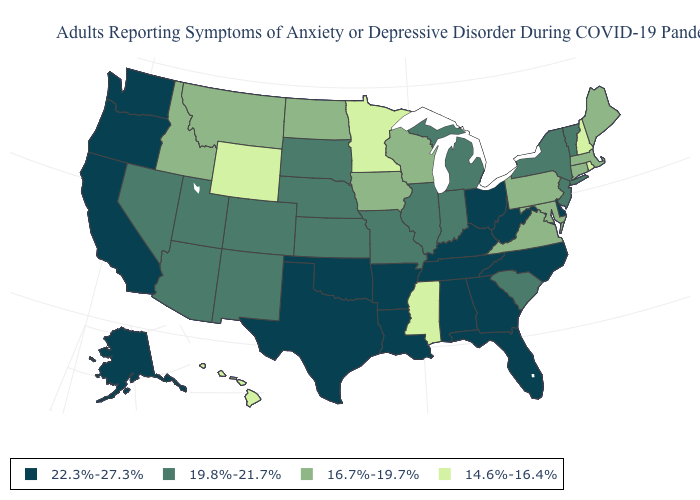Which states have the lowest value in the West?
Give a very brief answer. Hawaii, Wyoming. What is the value of West Virginia?
Short answer required. 22.3%-27.3%. What is the lowest value in the USA?
Keep it brief. 14.6%-16.4%. Name the states that have a value in the range 22.3%-27.3%?
Be succinct. Alabama, Alaska, Arkansas, California, Delaware, Florida, Georgia, Kentucky, Louisiana, North Carolina, Ohio, Oklahoma, Oregon, Tennessee, Texas, Washington, West Virginia. How many symbols are there in the legend?
Keep it brief. 4. How many symbols are there in the legend?
Keep it brief. 4. What is the lowest value in the West?
Concise answer only. 14.6%-16.4%. Name the states that have a value in the range 14.6%-16.4%?
Give a very brief answer. Hawaii, Minnesota, Mississippi, New Hampshire, Rhode Island, Wyoming. Does Oregon have a lower value than New Mexico?
Quick response, please. No. How many symbols are there in the legend?
Write a very short answer. 4. Name the states that have a value in the range 14.6%-16.4%?
Short answer required. Hawaii, Minnesota, Mississippi, New Hampshire, Rhode Island, Wyoming. What is the value of Nebraska?
Concise answer only. 19.8%-21.7%. Does the first symbol in the legend represent the smallest category?
Be succinct. No. What is the value of Maine?
Answer briefly. 16.7%-19.7%. What is the value of New Hampshire?
Write a very short answer. 14.6%-16.4%. 